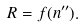<formula> <loc_0><loc_0><loc_500><loc_500>R = f ( n ^ { \prime \prime } ) .</formula> 